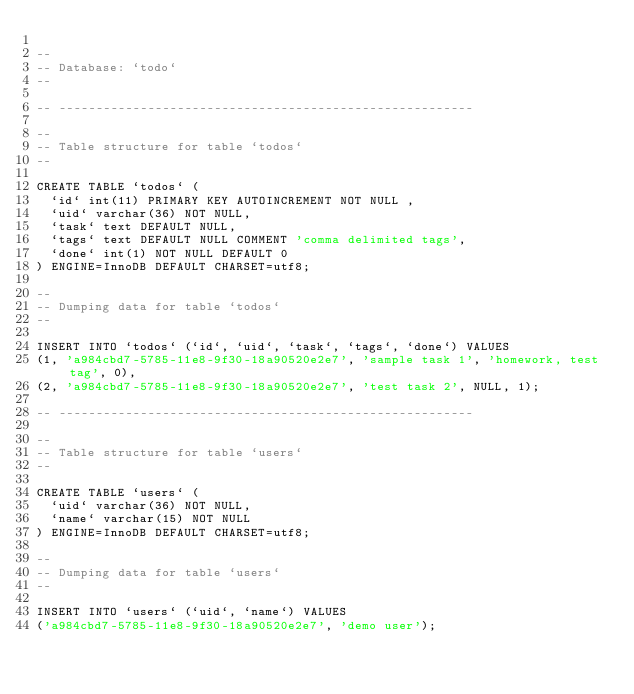<code> <loc_0><loc_0><loc_500><loc_500><_SQL_>
--
-- Database: `todo`
--

-- --------------------------------------------------------

--
-- Table structure for table `todos`
--

CREATE TABLE `todos` (
  `id` int(11) PRIMARY KEY AUTOINCREMENT NOT NULL ,
  `uid` varchar(36) NOT NULL,
  `task` text DEFAULT NULL,
  `tags` text DEFAULT NULL COMMENT 'comma delimited tags',
  `done` int(1) NOT NULL DEFAULT 0
) ENGINE=InnoDB DEFAULT CHARSET=utf8;

--
-- Dumping data for table `todos`
--

INSERT INTO `todos` (`id`, `uid`, `task`, `tags`, `done`) VALUES
(1, 'a984cbd7-5785-11e8-9f30-18a90520e2e7', 'sample task 1', 'homework, test tag', 0),
(2, 'a984cbd7-5785-11e8-9f30-18a90520e2e7', 'test task 2', NULL, 1);

-- --------------------------------------------------------

--
-- Table structure for table `users`
--

CREATE TABLE `users` (
  `uid` varchar(36) NOT NULL,
  `name` varchar(15) NOT NULL
) ENGINE=InnoDB DEFAULT CHARSET=utf8;

--
-- Dumping data for table `users`
--

INSERT INTO `users` (`uid`, `name`) VALUES
('a984cbd7-5785-11e8-9f30-18a90520e2e7', 'demo user');


</code> 